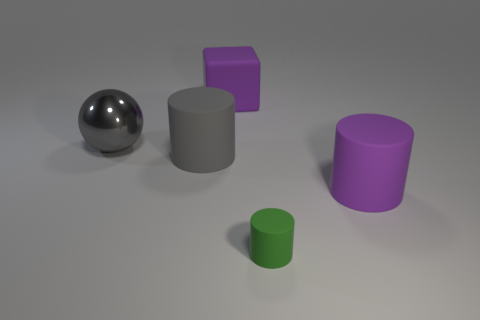Subtract all gray cylinders. How many cylinders are left? 2 Add 4 gray matte things. How many objects exist? 9 Subtract all gray cylinders. How many cylinders are left? 2 Subtract 1 balls. How many balls are left? 0 Subtract all cubes. How many objects are left? 4 Add 1 large rubber cubes. How many large rubber cubes are left? 2 Add 5 tiny green rubber cylinders. How many tiny green rubber cylinders exist? 6 Subtract 0 blue cylinders. How many objects are left? 5 Subtract all brown balls. Subtract all cyan blocks. How many balls are left? 1 Subtract all brown blocks. Subtract all large cylinders. How many objects are left? 3 